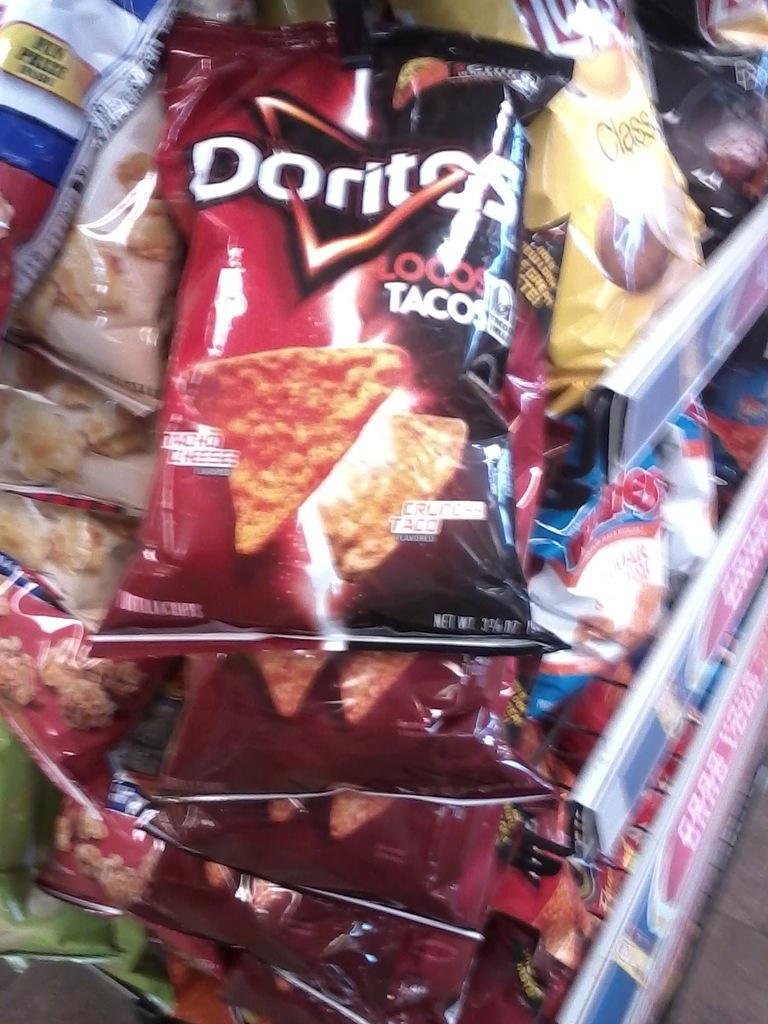<image>
Present a compact description of the photo's key features. Grocery cart full of bags of chips with Doritos in white lettering. 